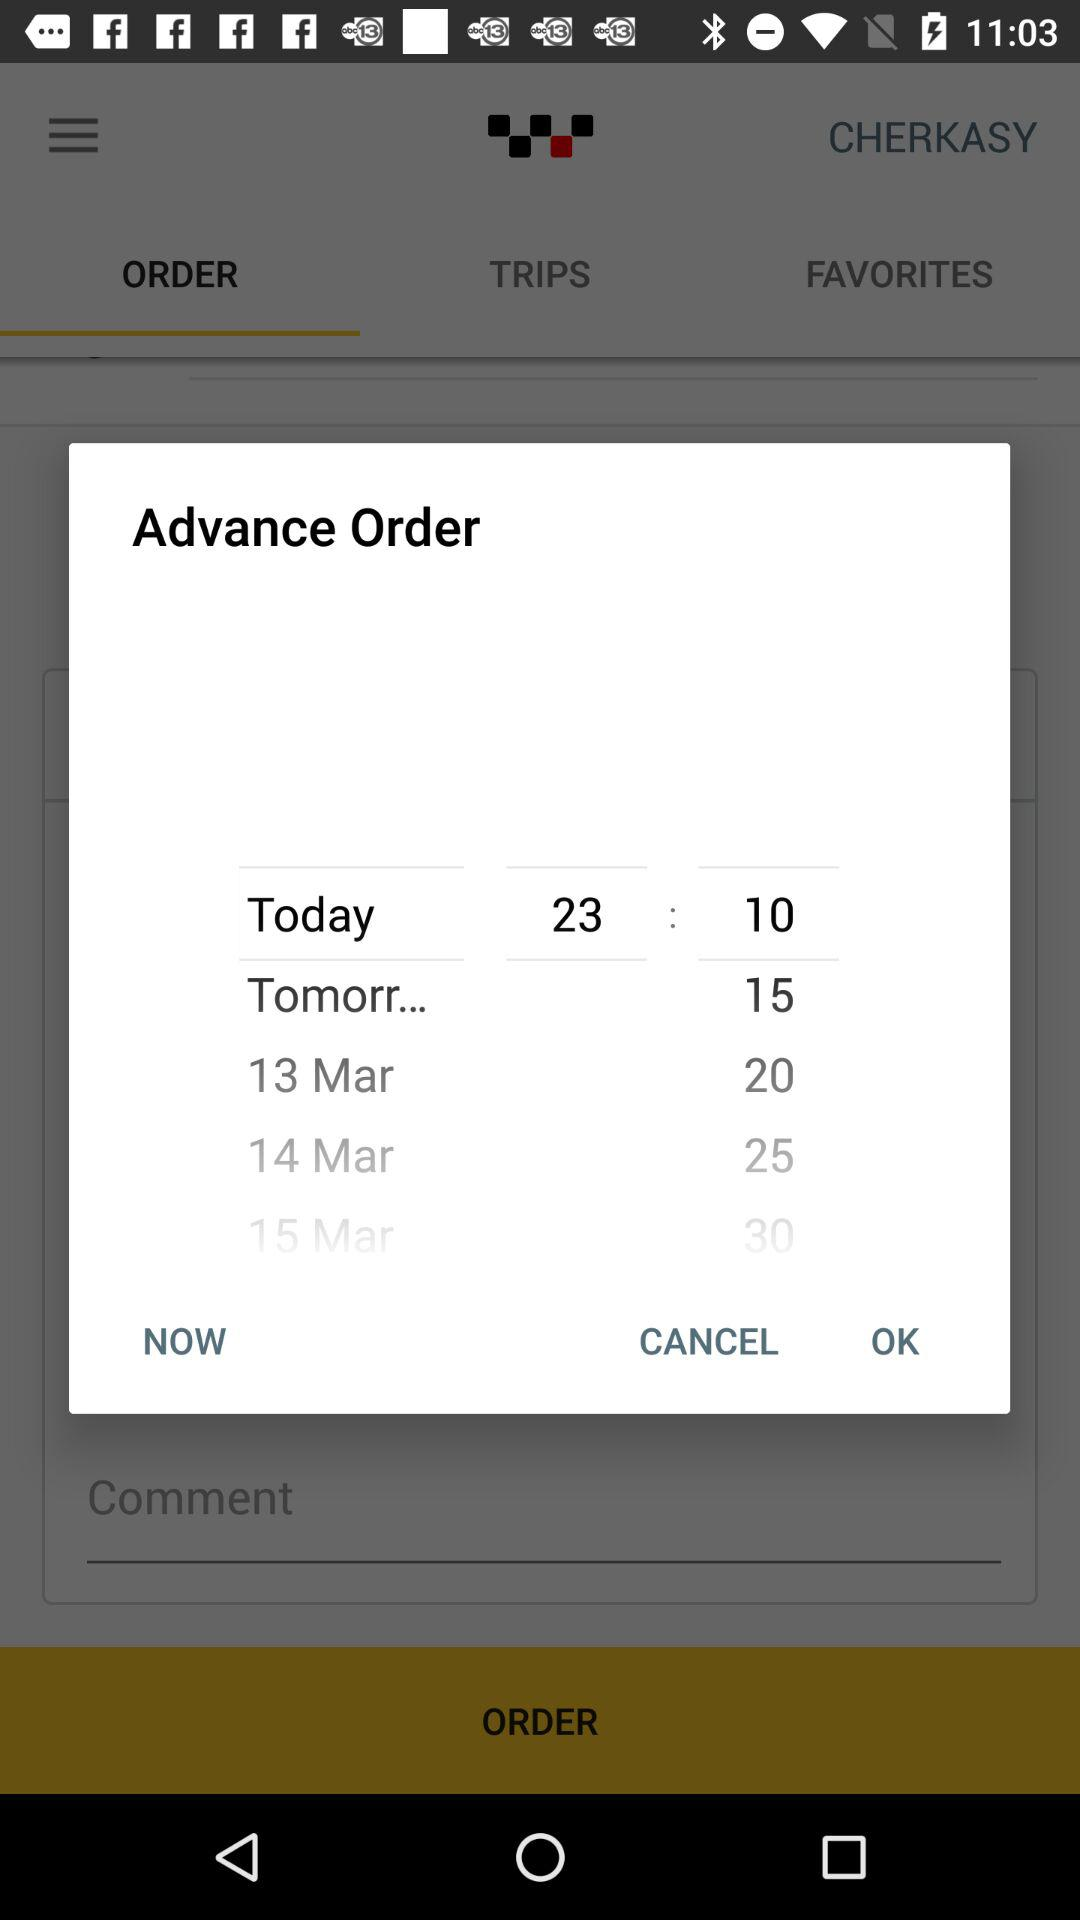What is the date mentioned in "Advance Order"? The mentioned dates are March 13, March 14 and March 15. 